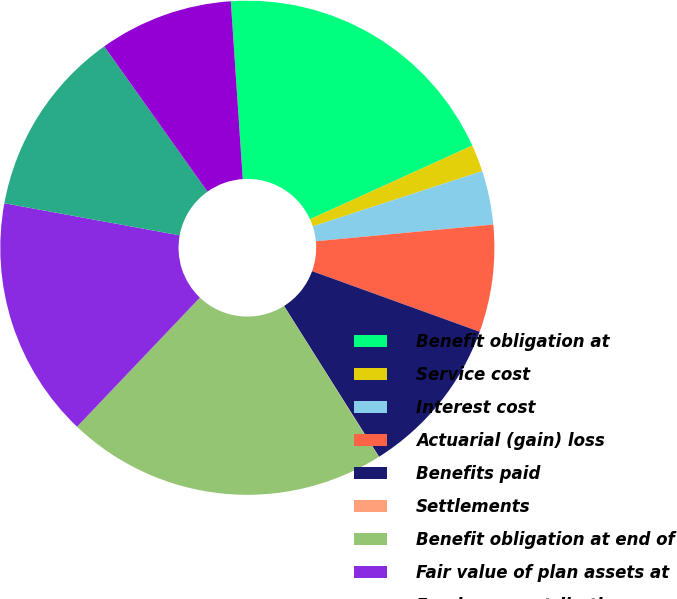<chart> <loc_0><loc_0><loc_500><loc_500><pie_chart><fcel>Benefit obligation at<fcel>Service cost<fcel>Interest cost<fcel>Actuarial (gain) loss<fcel>Benefits paid<fcel>Settlements<fcel>Benefit obligation at end of<fcel>Fair value of plan assets at<fcel>Employer contribution<fcel>Benefit payments<nl><fcel>19.28%<fcel>1.77%<fcel>3.52%<fcel>7.02%<fcel>10.53%<fcel>0.02%<fcel>21.03%<fcel>15.78%<fcel>12.28%<fcel>8.77%<nl></chart> 